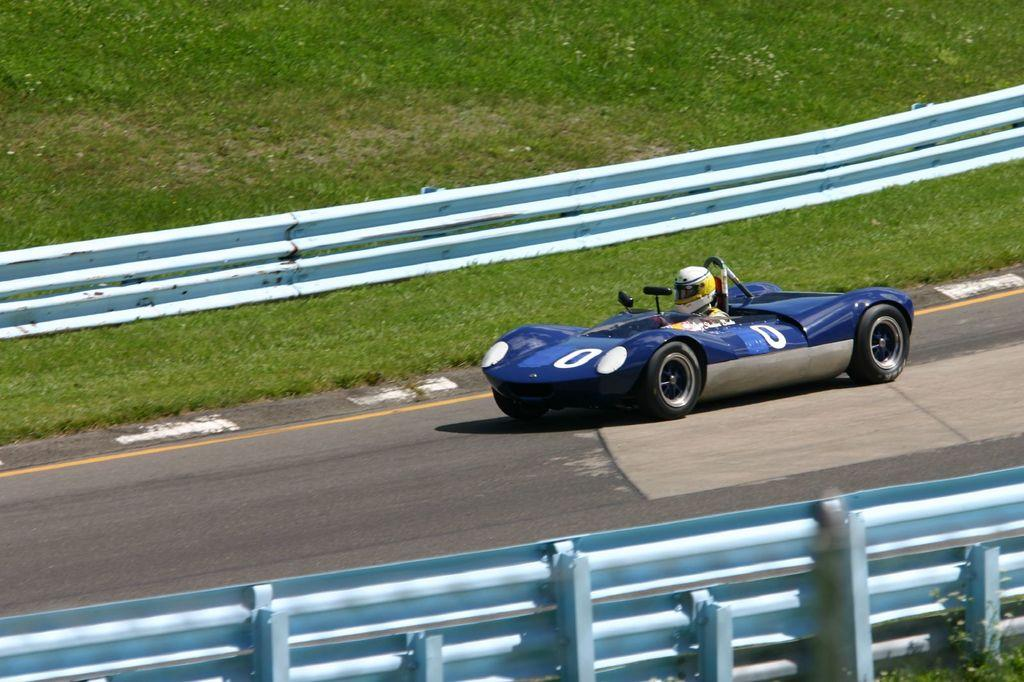What type of vehicle is in the foreground of the image? There is a sports car in the foreground of the image. What is the sports car doing in the image? The sports car is moving on a road. What can be seen on both sides of the road in the image? Railings are present on both sides of the road. What type of vegetation is visible in the image? Grass is visible in the image. What type of yoke is being used by the governor in the image? There is no governor or yoke present in the image. What is the tin used for in the image? There is no tin present in the image. 